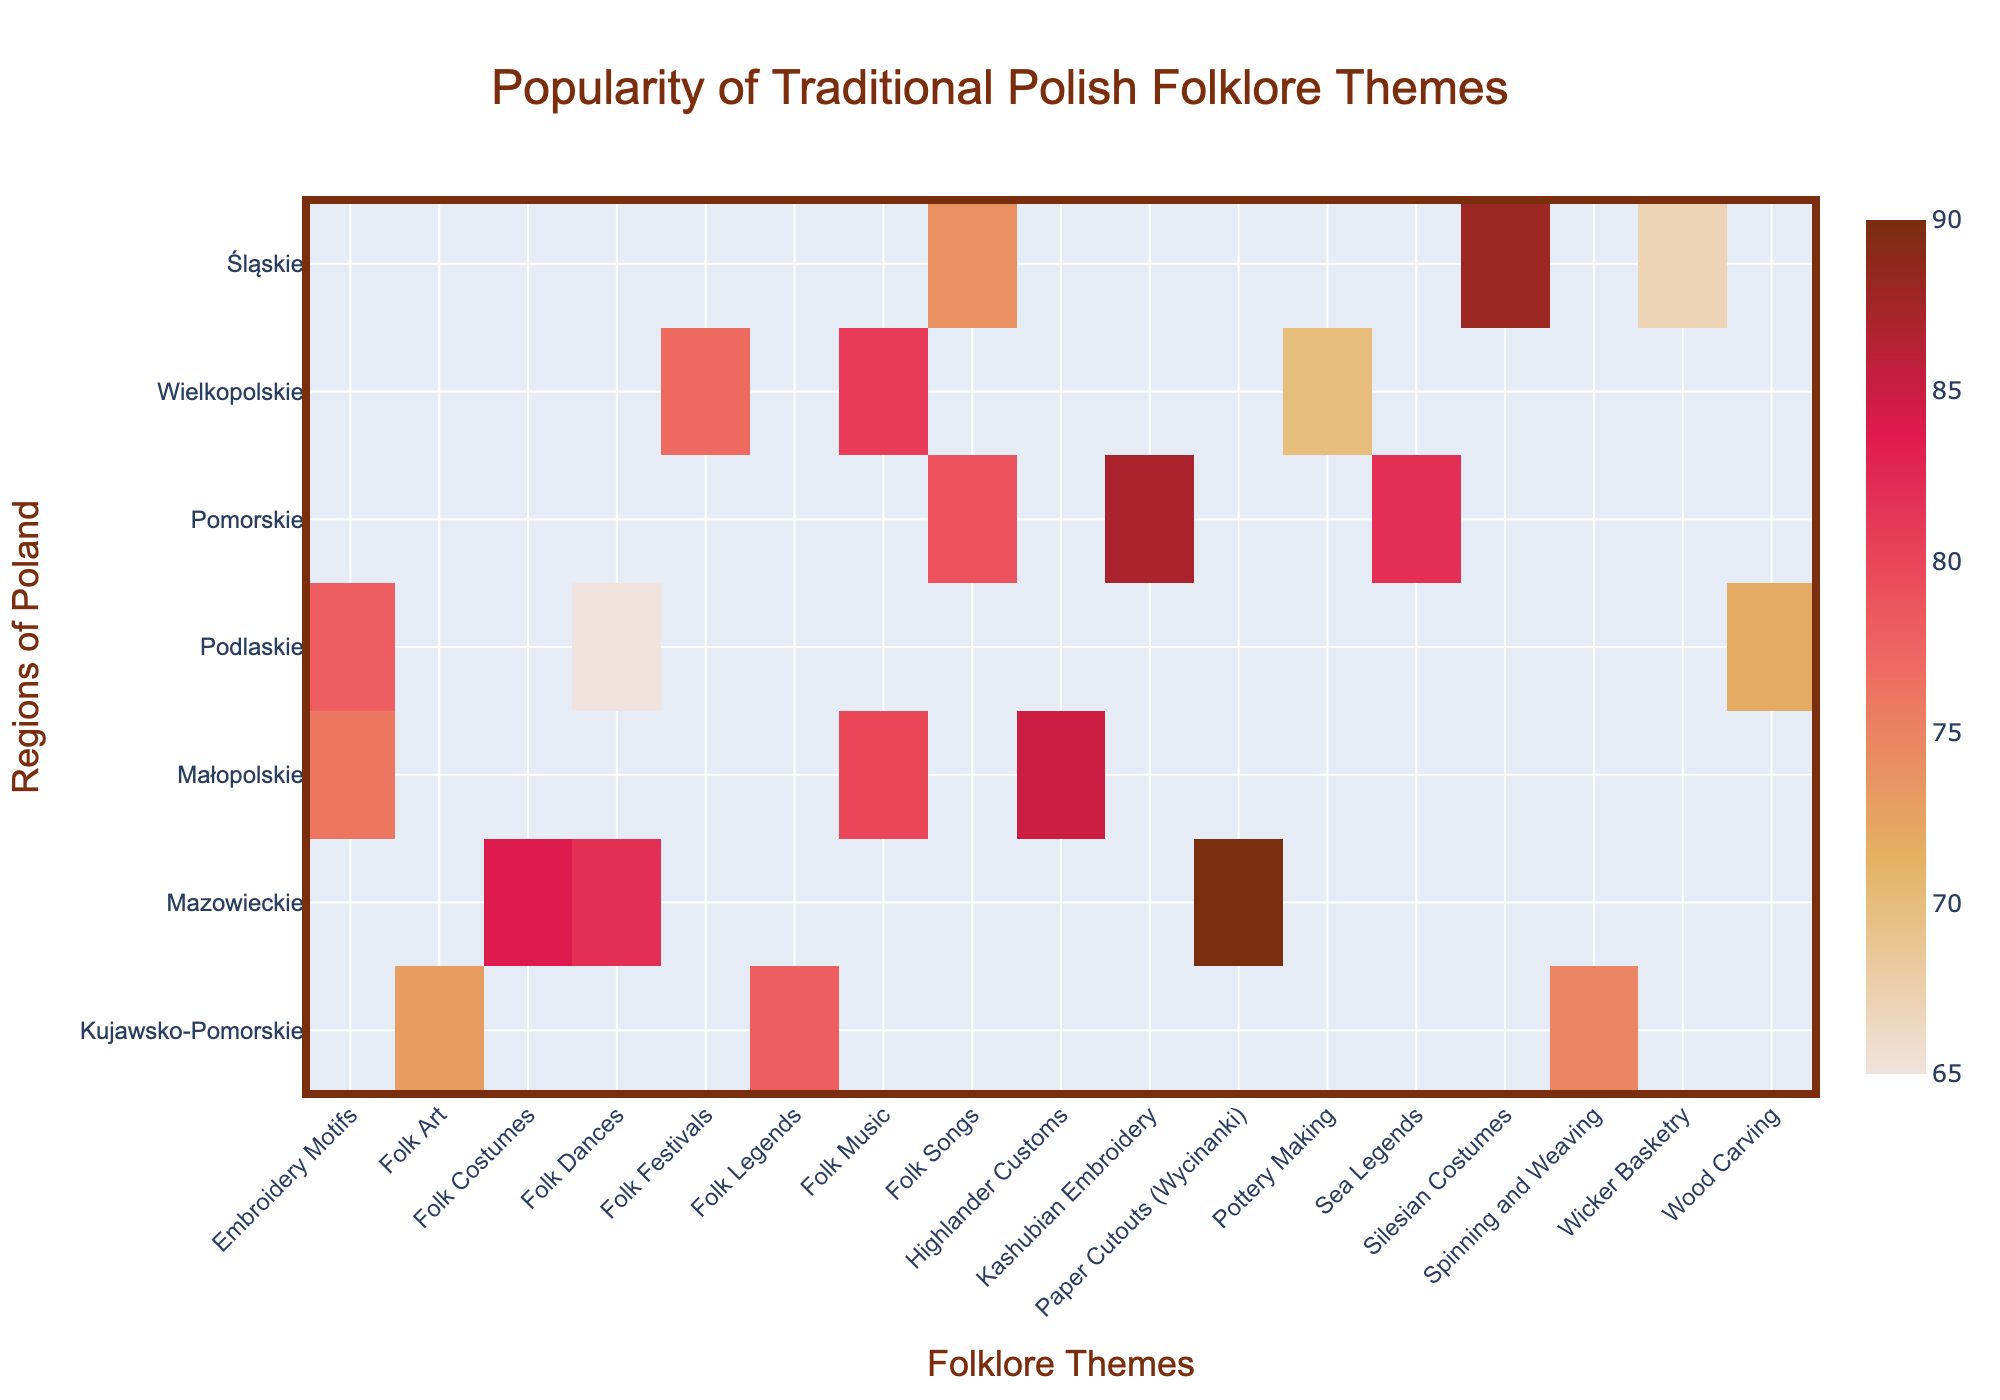What's the title of the heatmap? The title of the heatmap is located at the top center of the figure. It is designed to provide an overview of the data being visualized.
Answer: Popularity of Traditional Polish Folklore Themes Which region has the highest popularity for the theme "Paper Cutouts (Wycinanki)"? By locating the theme "Paper Cutouts (Wycinanki)" on the x-axis and finding where it intersects with the y-axis for each region, we can see that "Mazowieckie" has the highest popularity for this theme.
Answer: Mazowieckie Which theme is the most popular in Śląskie? To find the most popular theme in Śląskie, look at the intersection of the y-axis label "Śląskie" and compare the color intensities. The theme with the darkest color is the most popular.
Answer: Silesian Costumes What is the least popular theme in Kujawsko-Pomorskie? Checking the intersection of the y-axis label "Kujawsko-Pomorskie" and the x-axis labels, find the theme with the lightest color or the lowest value.
Answer: Folk Art What are the three most popular themes in Małopolskie? By analyzing the values associated with Małopolskie, sort the themes in descending order of popularity to find the top three.
Answer: Highlander Customs, Folk Music, Embroidery Motifs Which region is more popular for "Folk Music," Wielkopolskie or Małopolskie? Comparing the popularity values of "Folk Music" for Wielkopolskie and Małopolskie will show which region has a higher value or darker color intensity.
Answer: Małopolskie Is the theme "Folk Dances" more popular in Mazowieckie or Podlaskie, and by how much? Check the popularity values for "Folk Dances" in both Mazowieckie and Podlaskie. Subtract the lower value from the higher value to find the difference.
Answer: Mazowieckie is more popular by 17 (82 - 65) What is the average popularity of all themes in Pomorskie? Sum the popularity values for all themes in Pomorskie and divide by the number of themes. There are three themes, so (87 + 79 + 82) / 3 = 82.67.
Answer: 82.67 Which theme has consistent popularity (least variation) across all regions? To determine the theme with the least variation, look at the intensity of colors for each theme across all regions and identify the one with the least fluctuation.
Answer: Embroidery Motifs What's the difference in popularity between "Wood Carving" in Podlaskie and "Pottery Making" in Wielkopolskie? Find the popularity values of "Wood Carving" in Podlaskie and "Pottery Making" in Wielkopolskie, then subtract the smaller value from the larger one.
Answer: 2 (72 - 70) 